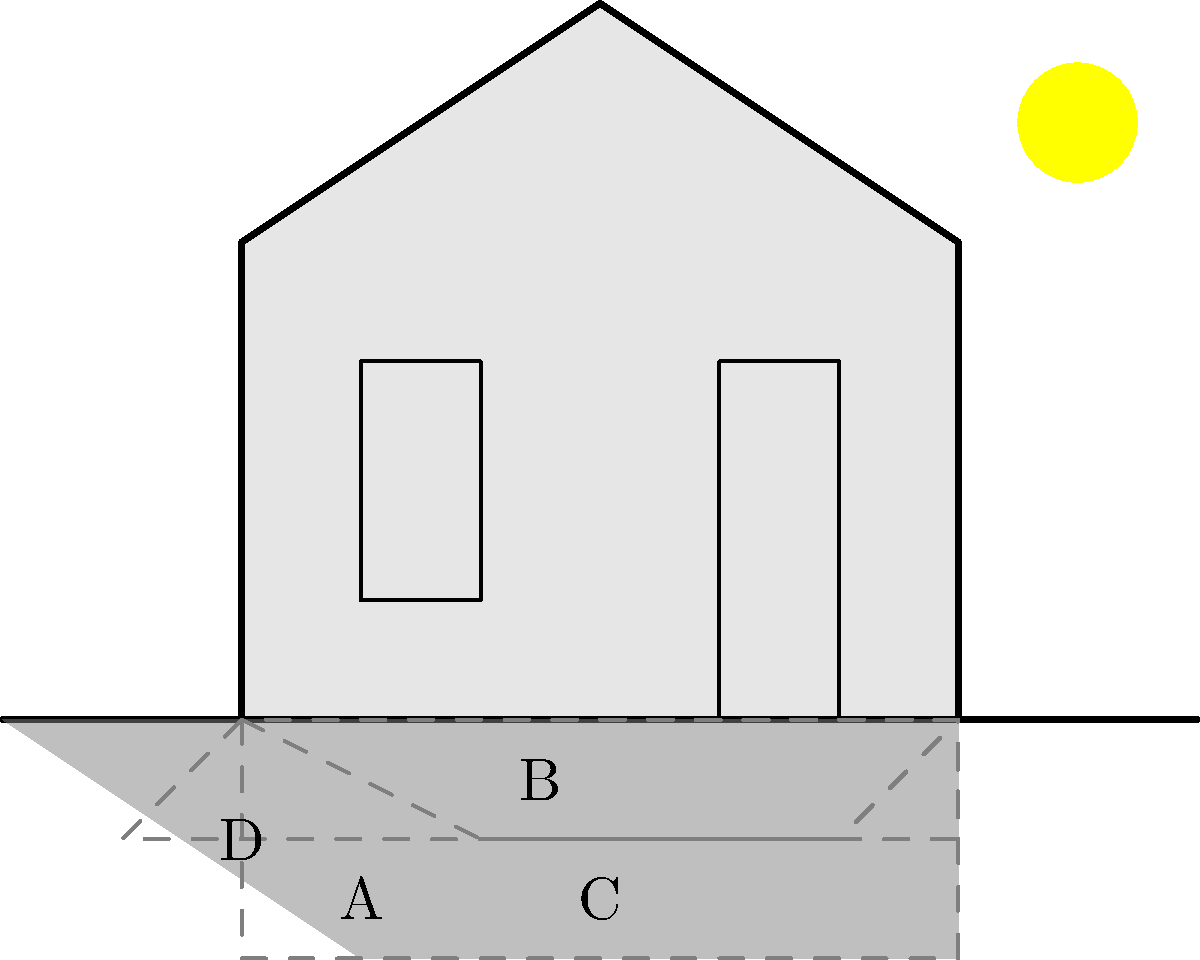Eyy, me fellow Bajan art lover! Take a gander at this traditional chattel house basking in the sunshine. Now, which of these shadows be telling the true story of our beloved little home? Is it shadow A, B, C, or D? Let's see if you can spot the real deal, no long talk! Alright, let's break this down like we're dissecting the latest rumor at the fish market:

1. First things first, we need to look at where the sun be shining from. In the picture, we can see that big ol' ball of fire up in the top right corner.

2. Now, knowing how light works (and trust me, as an artist, I know my light!), the shadow should be cast in the opposite direction from the sun. That means our shadow should stretch out to the bottom left.

3. Let's look at each shadow:
   - Shadow B is going to the right, which is a no-go. The sun would have to be on the left for that to happen.
   - Shadow D is too short and straight down. That'd only happen if the sun was directly overhead, and we can see it ain't.
   - Shadow C is a bit better, but it's not stretching far enough to the left.
   - Shadow A is the only one that's stretching far enough to the bottom left, matching the sun's position.

4. Additionally, Shadow A is the only one that's showing the shape of the roof properly. See how it's got that little peak? That's our chattel house's gable roof right there!

5. Lastly, the length of Shadow A makes sense. When the sun's lower in the sky (like it is here), shadows get longer. A's the longest shadow, which fits with the sun's position.

So, putting all that together like pieces of a colorful mural, Shadow A is the only one that's telling the truth about our charming little chattel house.
Answer: A 